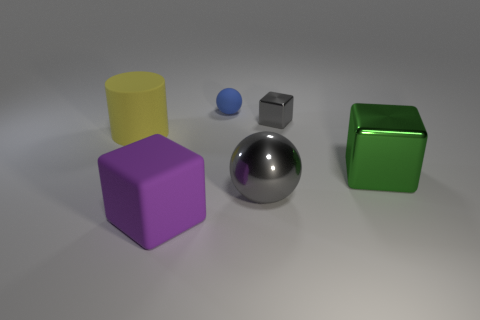Subtract all green metal cubes. How many cubes are left? 2 Add 2 cyan rubber balls. How many objects exist? 8 Subtract all green blocks. How many blocks are left? 2 Subtract 1 balls. How many balls are left? 1 Subtract all spheres. How many objects are left? 4 Subtract all cyan balls. Subtract all yellow blocks. How many balls are left? 2 Add 5 big blue blocks. How many big blue blocks exist? 5 Subtract 0 red cylinders. How many objects are left? 6 Subtract all blue balls. How many gray cubes are left? 1 Subtract all tiny balls. Subtract all big purple objects. How many objects are left? 4 